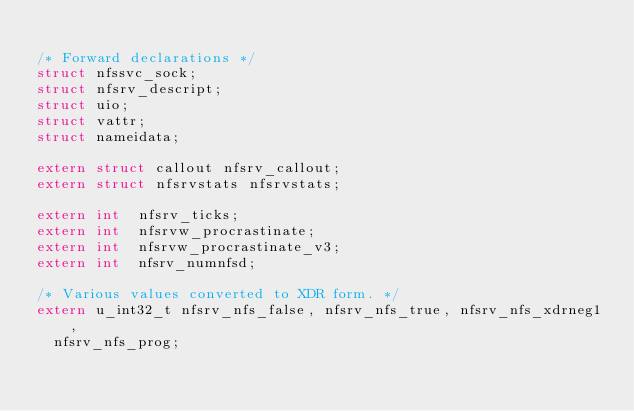<code> <loc_0><loc_0><loc_500><loc_500><_C_>
/* Forward declarations */
struct nfssvc_sock;
struct nfsrv_descript;
struct uio;
struct vattr;
struct nameidata;

extern struct callout nfsrv_callout;
extern struct nfsrvstats nfsrvstats;

extern int	nfsrv_ticks;
extern int	nfsrvw_procrastinate;
extern int	nfsrvw_procrastinate_v3;
extern int 	nfsrv_numnfsd;

/* Various values converted to XDR form. */
extern u_int32_t nfsrv_nfs_false, nfsrv_nfs_true, nfsrv_nfs_xdrneg1,
	nfsrv_nfs_prog;</code> 